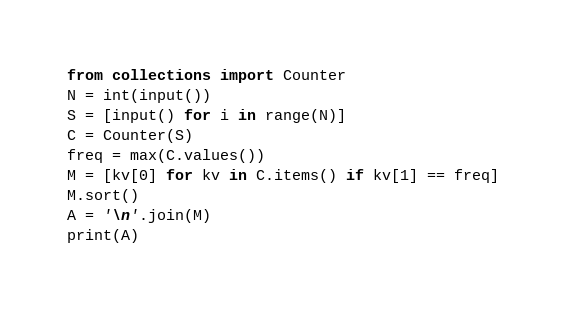<code> <loc_0><loc_0><loc_500><loc_500><_Python_>from collections import Counter
N = int(input())
S = [input() for i in range(N)]
C = Counter(S)
freq = max(C.values())
M = [kv[0] for kv in C.items() if kv[1] == freq]
M.sort()
A = '\n'.join(M)
print(A)</code> 